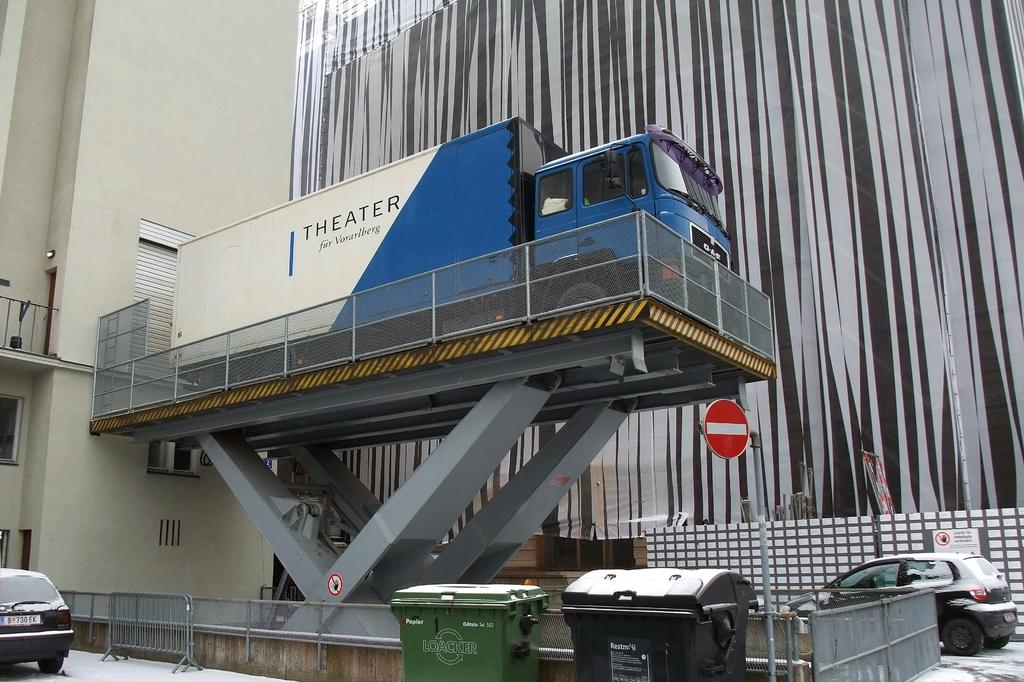<image>
Give a short and clear explanation of the subsequent image. A white and blue truck says "THEATER" on the side. 